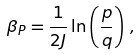Convert formula to latex. <formula><loc_0><loc_0><loc_500><loc_500>\beta _ { P } = \frac { 1 } { 2 J } \ln \left ( \frac { p } { q } \right ) \, ,</formula> 